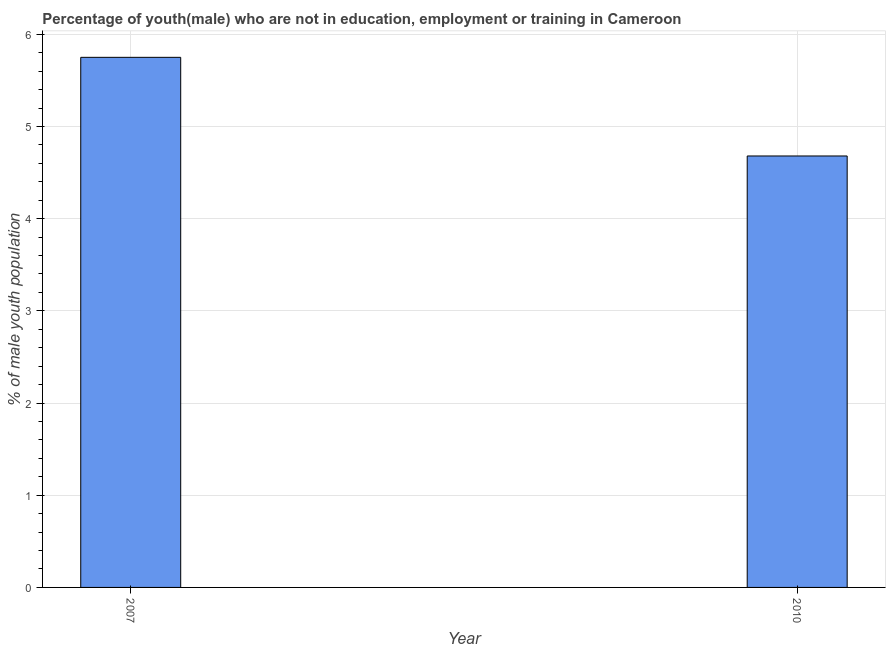Does the graph contain any zero values?
Your answer should be compact. No. Does the graph contain grids?
Keep it short and to the point. Yes. What is the title of the graph?
Give a very brief answer. Percentage of youth(male) who are not in education, employment or training in Cameroon. What is the label or title of the Y-axis?
Make the answer very short. % of male youth population. What is the unemployed male youth population in 2007?
Offer a terse response. 5.75. Across all years, what is the maximum unemployed male youth population?
Make the answer very short. 5.75. Across all years, what is the minimum unemployed male youth population?
Give a very brief answer. 4.68. In which year was the unemployed male youth population minimum?
Your answer should be compact. 2010. What is the sum of the unemployed male youth population?
Give a very brief answer. 10.43. What is the difference between the unemployed male youth population in 2007 and 2010?
Your answer should be very brief. 1.07. What is the average unemployed male youth population per year?
Make the answer very short. 5.21. What is the median unemployed male youth population?
Provide a short and direct response. 5.21. In how many years, is the unemployed male youth population greater than 2.2 %?
Provide a succinct answer. 2. Do a majority of the years between 2007 and 2010 (inclusive) have unemployed male youth population greater than 5.6 %?
Ensure brevity in your answer.  No. What is the ratio of the unemployed male youth population in 2007 to that in 2010?
Offer a very short reply. 1.23. Is the unemployed male youth population in 2007 less than that in 2010?
Keep it short and to the point. No. How many bars are there?
Provide a succinct answer. 2. Are all the bars in the graph horizontal?
Keep it short and to the point. No. How many years are there in the graph?
Provide a succinct answer. 2. What is the difference between two consecutive major ticks on the Y-axis?
Your response must be concise. 1. Are the values on the major ticks of Y-axis written in scientific E-notation?
Keep it short and to the point. No. What is the % of male youth population of 2007?
Make the answer very short. 5.75. What is the % of male youth population in 2010?
Offer a terse response. 4.68. What is the difference between the % of male youth population in 2007 and 2010?
Keep it short and to the point. 1.07. What is the ratio of the % of male youth population in 2007 to that in 2010?
Offer a terse response. 1.23. 